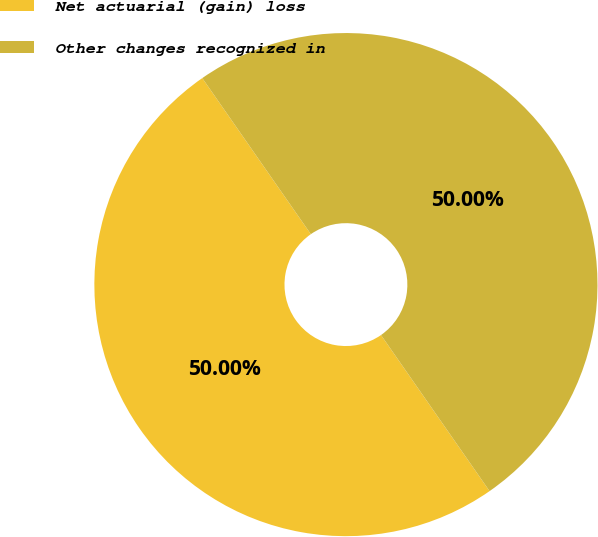Convert chart to OTSL. <chart><loc_0><loc_0><loc_500><loc_500><pie_chart><fcel>Net actuarial (gain) loss<fcel>Other changes recognized in<nl><fcel>50.0%<fcel>50.0%<nl></chart> 